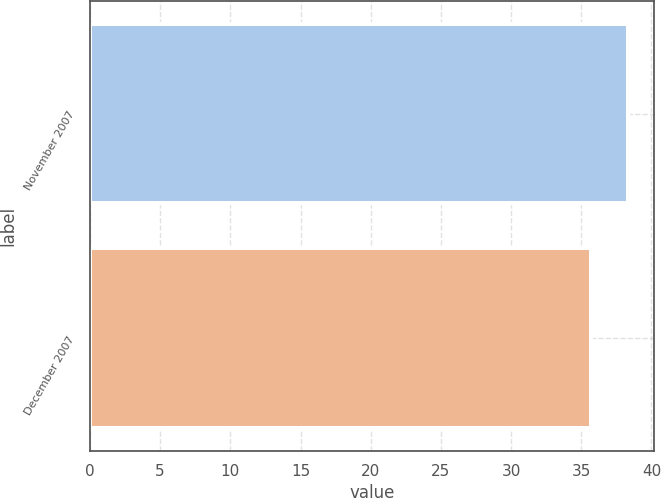Convert chart. <chart><loc_0><loc_0><loc_500><loc_500><bar_chart><fcel>November 2007<fcel>December 2007<nl><fcel>38.3<fcel>35.69<nl></chart> 